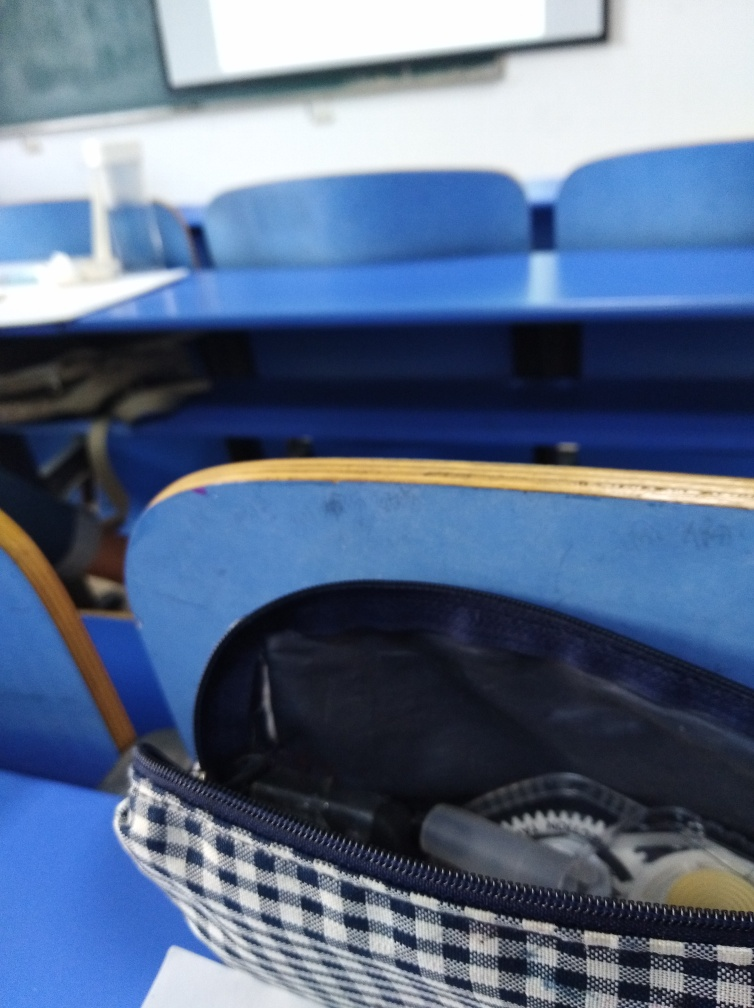Is the focus too close to the lower part of the frame? The focus appears to be on the foreground, particularly on the pencil case. This can create a sense of intimacy and immediacy, while the background, including the blue chairs and whiteboard, is blurred, which diminishes the potential for distractions from the main subject. 